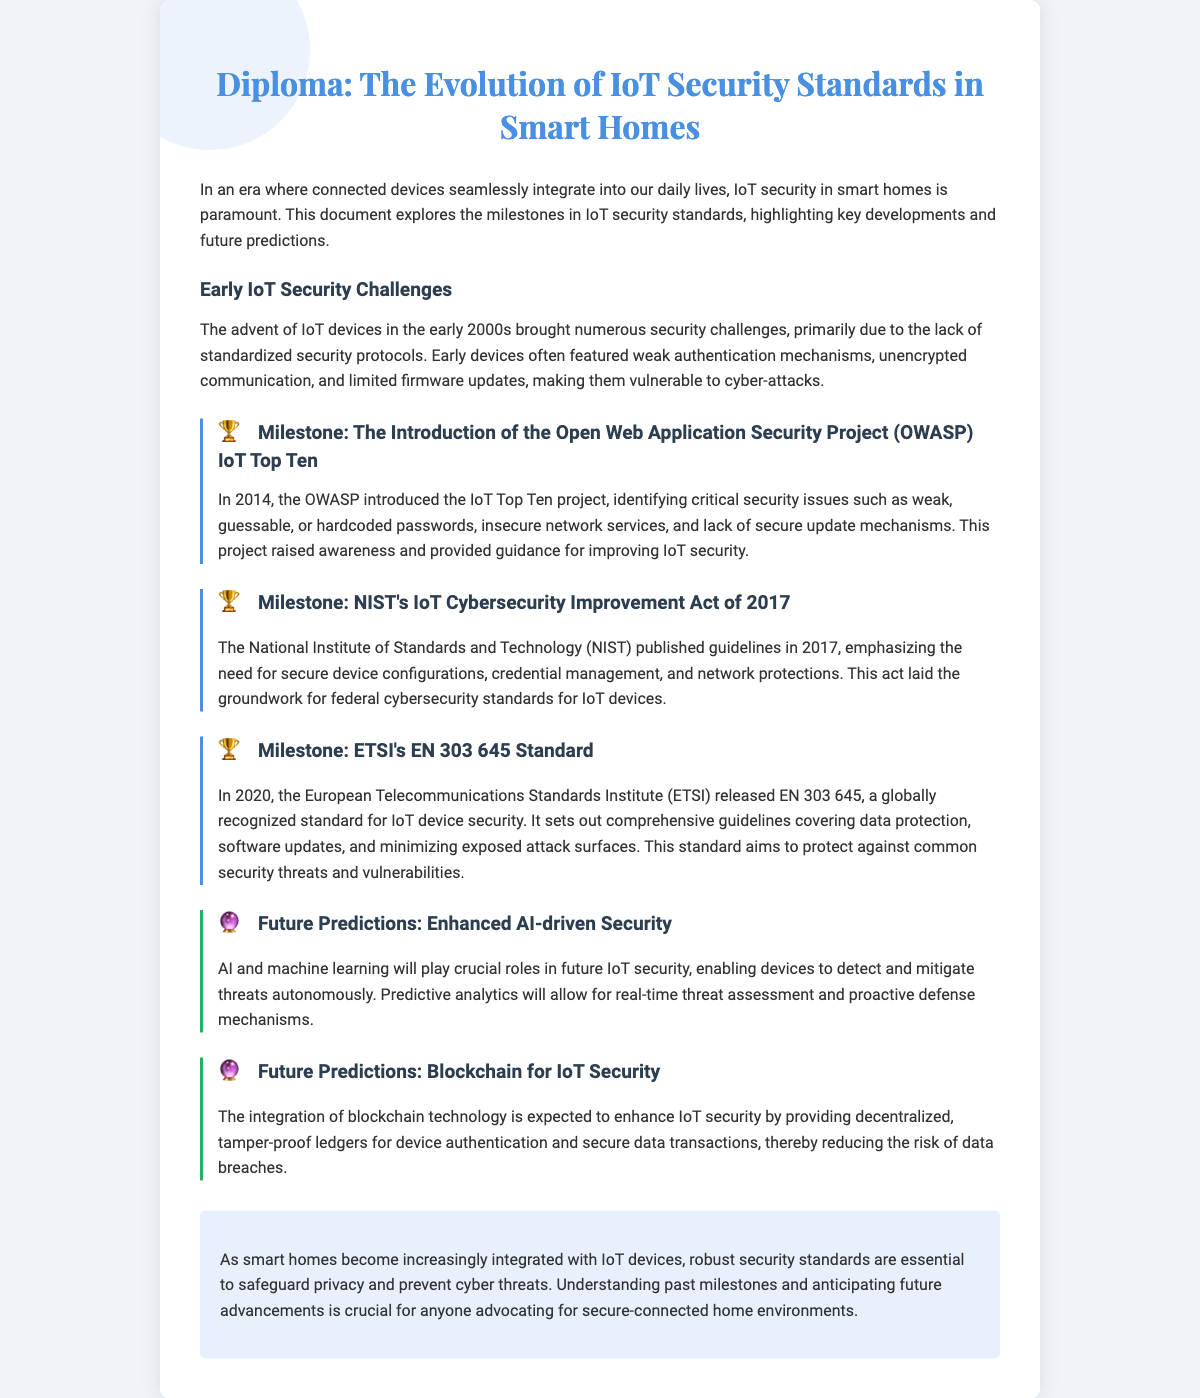What is the title of the document? The title of the document is mentioned prominently at the top, indicating the topic covered.
Answer: The Evolution of IoT Security Standards in Smart Homes What year was the OWASP IoT Top Ten introduced? The document specifies the year the OWASP IoT Top Ten project was introduced as a key milestone.
Answer: 2014 What is the main focus of NIST's IoT Cybersecurity Improvement Act of 2017? The document describes the main focus of the NIST guidelines as it relates to securing IoT devices.
Answer: Secure device configurations What is the EN 303 645 standard related to? The document highlights the EN 303 645 standard and its implications for IoT security.
Answer: IoT device security What technology is predicted to enhance IoT security in the future? The document discusses future predictions for IoT security improvements, identifying specific technologies.
Answer: AI and machine learning How does the document describe early IoT security challenges? The document outlines the primary issues in IoT security that existed during the early 2000s.
Answer: Lack of standardized security protocols What is one of the future predictions for IoT security mentioned in the document? The document makes specific predictions regarding advancements that will enhance IoT security.
Answer: Blockchain for IoT Security What function does the OWASP IoT Top Ten project serve? The document states the purpose of the OWASP IoT Top Ten project with respect to IoT security.
Answer: Identifying critical security issues What is essential for safeguarding privacy in smart homes? The document emphasizes the importance of a particular aspect of IoT adoption in smart homes.
Answer: Robust security standards 